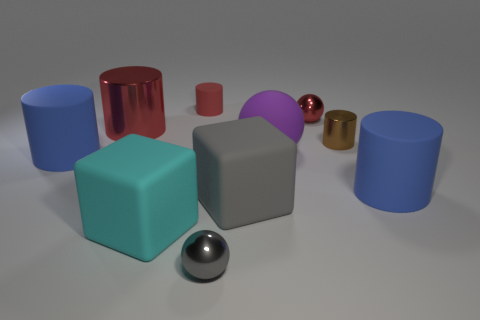What color is the big block that is right of the sphere that is in front of the big blue rubber object to the right of the big red metal cylinder?
Make the answer very short. Gray. Are the gray cube and the small brown thing made of the same material?
Your answer should be very brief. No. How many gray things are tiny objects or large metal objects?
Provide a short and direct response. 1. There is a large gray rubber cube; what number of small shiny things are right of it?
Your answer should be compact. 2. Are there more tiny metallic spheres than tiny shiny objects?
Ensure brevity in your answer.  No. There is a metal object in front of the large thing to the right of the tiny red metal object; what is its shape?
Your answer should be very brief. Sphere. Is the large metallic object the same color as the big rubber sphere?
Your answer should be very brief. No. Is the number of shiny objects to the right of the gray rubber object greater than the number of big blue things?
Your answer should be compact. No. What number of small red cylinders are in front of the blue cylinder that is to the left of the small brown metallic cylinder?
Your answer should be compact. 0. Do the big blue object that is to the right of the small red matte thing and the small ball that is on the left side of the tiny red shiny ball have the same material?
Your answer should be compact. No. 